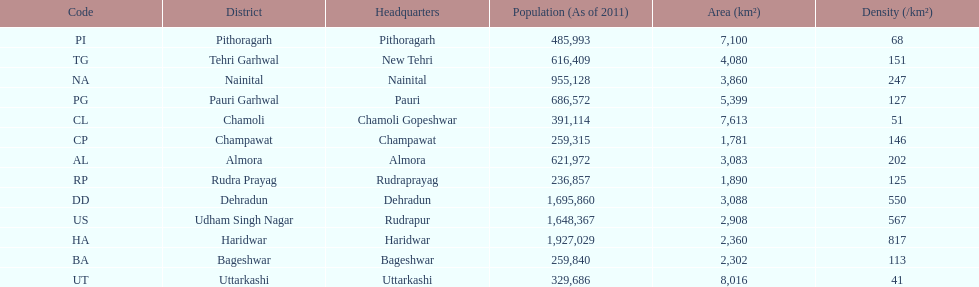If a person was headquartered in almora what would be his/her district? Almora. 